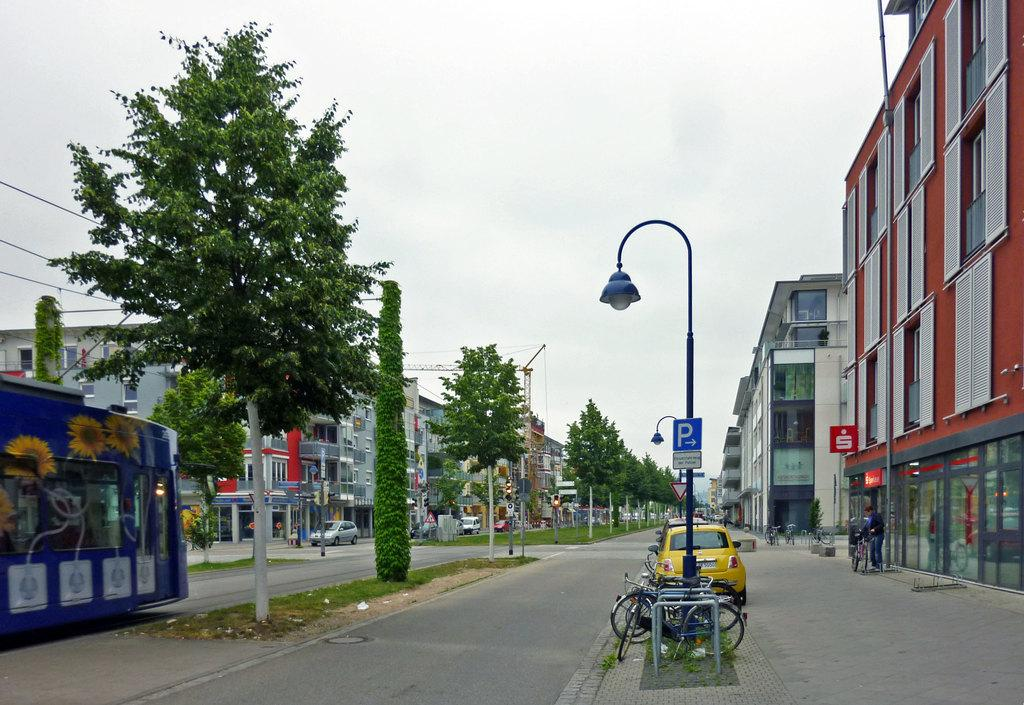What type of structures can be seen in the image? There are buildings in the image. What is present on the road in the image? There are vehicles on the road in the image. What type of vegetation is visible in the image? There are trees and grass in the image. What type of lighting is present in the image? There is a street light in the image. What type of construction equipment is visible in the image? There is a crane in the image. What part of the natural environment is visible in the image? The sky is visible in the image. Where is the ornament located in the image? There is no ornament present in the image. What type of cave can be seen in the image? There is no cave present in the image. 